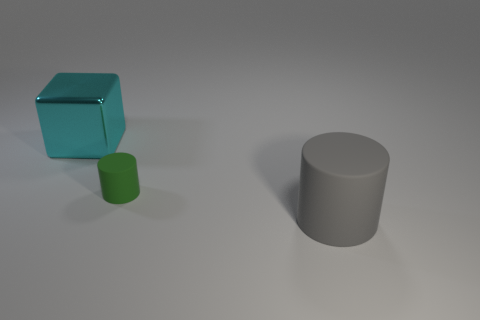Add 3 gray objects. How many objects exist? 6 Subtract all cylinders. How many objects are left? 1 Add 2 large things. How many large things exist? 4 Subtract 0 red cylinders. How many objects are left? 3 Subtract all green things. Subtract all big shiny things. How many objects are left? 1 Add 1 large cyan metal blocks. How many large cyan metal blocks are left? 2 